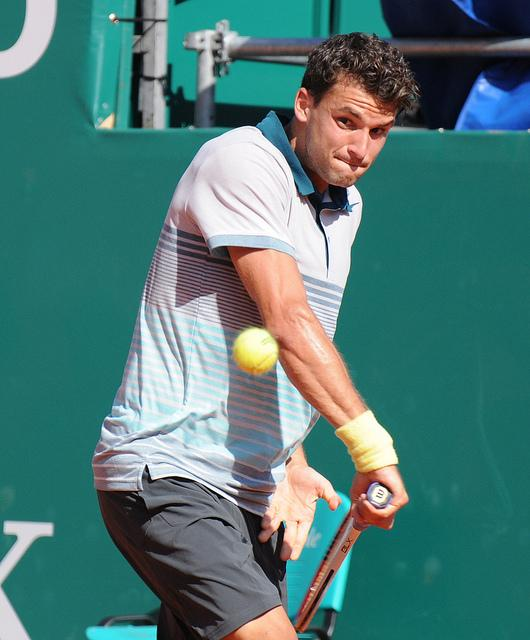What technique does this player utilize here?

Choices:
A) underhanded
B) avoidance
C) overhanded
D) back handed back handed 